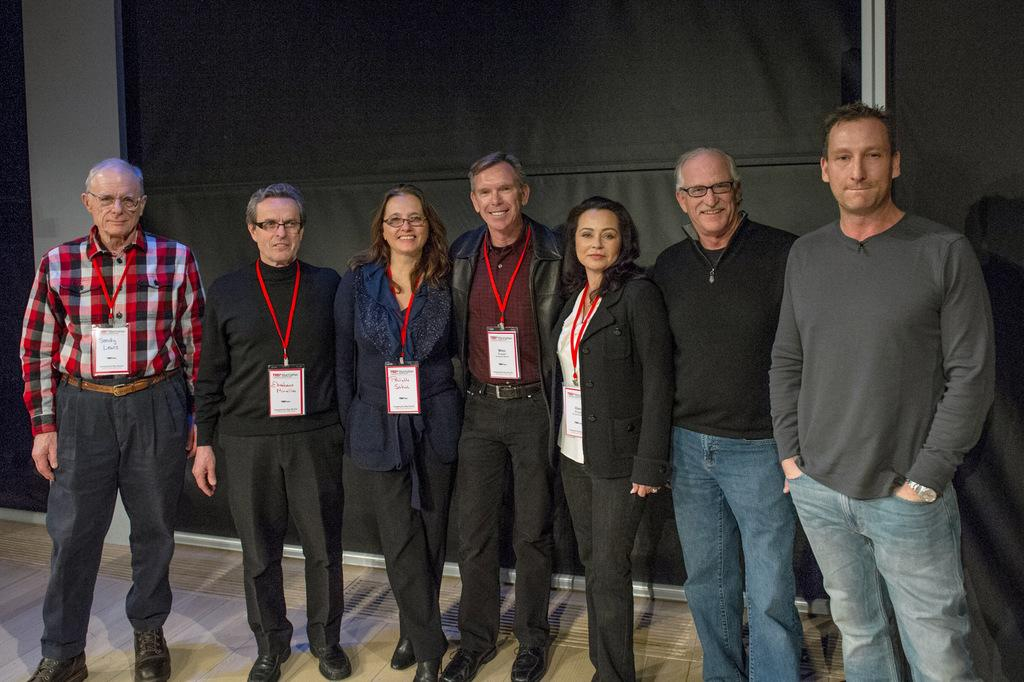What are the main subjects in the image? There are people standing in the center of the image. What can be seen in the background of the image? There is a wall and a curtain in the background of the image. What type of amusement can be seen in the image? There is no amusement present in the image; it features people standing in front of a wall and a curtain. Can you describe the mountain range visible in the image? There is no mountain range present in the image. 